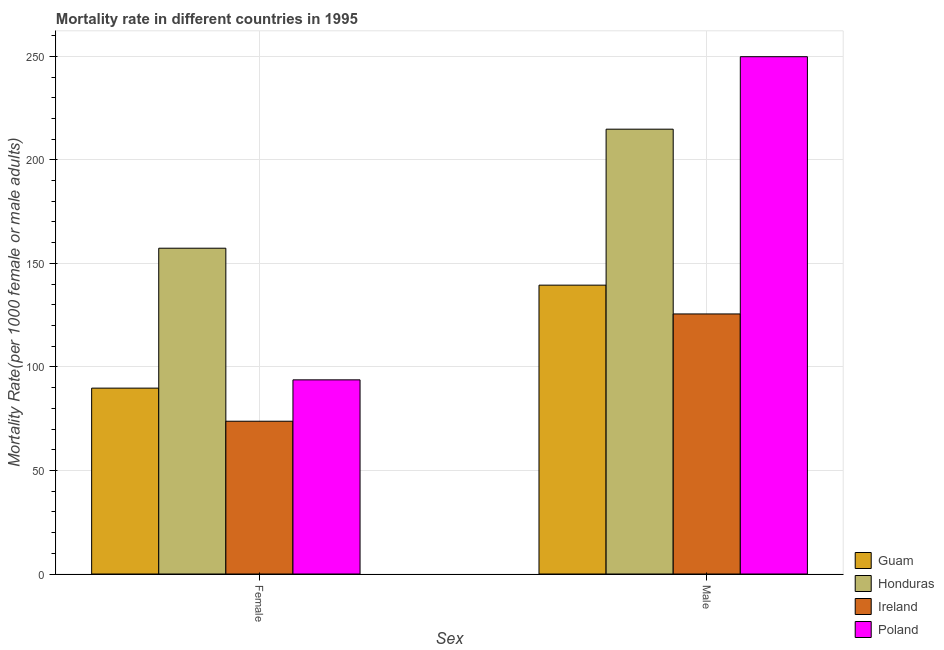How many groups of bars are there?
Provide a succinct answer. 2. Are the number of bars on each tick of the X-axis equal?
Make the answer very short. Yes. How many bars are there on the 2nd tick from the left?
Provide a succinct answer. 4. How many bars are there on the 2nd tick from the right?
Your response must be concise. 4. What is the male mortality rate in Ireland?
Offer a very short reply. 125.59. Across all countries, what is the maximum female mortality rate?
Give a very brief answer. 157.34. Across all countries, what is the minimum male mortality rate?
Your answer should be very brief. 125.59. In which country was the female mortality rate maximum?
Ensure brevity in your answer.  Honduras. In which country was the female mortality rate minimum?
Provide a succinct answer. Ireland. What is the total female mortality rate in the graph?
Offer a very short reply. 414.65. What is the difference between the female mortality rate in Guam and that in Poland?
Give a very brief answer. -4. What is the difference between the male mortality rate in Honduras and the female mortality rate in Ireland?
Provide a succinct answer. 141.05. What is the average male mortality rate per country?
Provide a short and direct response. 182.44. What is the difference between the female mortality rate and male mortality rate in Poland?
Provide a succinct answer. -156.07. What is the ratio of the female mortality rate in Honduras to that in Ireland?
Make the answer very short. 2.13. Is the female mortality rate in Ireland less than that in Poland?
Provide a short and direct response. Yes. What does the 3rd bar from the left in Male represents?
Your response must be concise. Ireland. What does the 4th bar from the right in Male represents?
Your answer should be compact. Guam. How many bars are there?
Offer a very short reply. 8. Are all the bars in the graph horizontal?
Keep it short and to the point. No. Are the values on the major ticks of Y-axis written in scientific E-notation?
Keep it short and to the point. No. How many legend labels are there?
Ensure brevity in your answer.  4. How are the legend labels stacked?
Provide a short and direct response. Vertical. What is the title of the graph?
Your response must be concise. Mortality rate in different countries in 1995. What is the label or title of the X-axis?
Your answer should be compact. Sex. What is the label or title of the Y-axis?
Your response must be concise. Mortality Rate(per 1000 female or male adults). What is the Mortality Rate(per 1000 female or male adults) of Guam in Female?
Your answer should be compact. 89.77. What is the Mortality Rate(per 1000 female or male adults) in Honduras in Female?
Offer a terse response. 157.34. What is the Mortality Rate(per 1000 female or male adults) of Ireland in Female?
Make the answer very short. 73.78. What is the Mortality Rate(per 1000 female or male adults) in Poland in Female?
Provide a succinct answer. 93.76. What is the Mortality Rate(per 1000 female or male adults) of Guam in Male?
Provide a succinct answer. 139.5. What is the Mortality Rate(per 1000 female or male adults) of Honduras in Male?
Keep it short and to the point. 214.83. What is the Mortality Rate(per 1000 female or male adults) in Ireland in Male?
Provide a short and direct response. 125.59. What is the Mortality Rate(per 1000 female or male adults) of Poland in Male?
Your response must be concise. 249.83. Across all Sex, what is the maximum Mortality Rate(per 1000 female or male adults) in Guam?
Make the answer very short. 139.5. Across all Sex, what is the maximum Mortality Rate(per 1000 female or male adults) in Honduras?
Give a very brief answer. 214.83. Across all Sex, what is the maximum Mortality Rate(per 1000 female or male adults) in Ireland?
Your answer should be compact. 125.59. Across all Sex, what is the maximum Mortality Rate(per 1000 female or male adults) of Poland?
Your answer should be very brief. 249.83. Across all Sex, what is the minimum Mortality Rate(per 1000 female or male adults) in Guam?
Make the answer very short. 89.77. Across all Sex, what is the minimum Mortality Rate(per 1000 female or male adults) in Honduras?
Keep it short and to the point. 157.34. Across all Sex, what is the minimum Mortality Rate(per 1000 female or male adults) in Ireland?
Make the answer very short. 73.78. Across all Sex, what is the minimum Mortality Rate(per 1000 female or male adults) in Poland?
Ensure brevity in your answer.  93.76. What is the total Mortality Rate(per 1000 female or male adults) of Guam in the graph?
Offer a terse response. 229.26. What is the total Mortality Rate(per 1000 female or male adults) in Honduras in the graph?
Offer a terse response. 372.17. What is the total Mortality Rate(per 1000 female or male adults) in Ireland in the graph?
Your answer should be very brief. 199.37. What is the total Mortality Rate(per 1000 female or male adults) of Poland in the graph?
Offer a terse response. 343.59. What is the difference between the Mortality Rate(per 1000 female or male adults) in Guam in Female and that in Male?
Give a very brief answer. -49.73. What is the difference between the Mortality Rate(per 1000 female or male adults) in Honduras in Female and that in Male?
Your answer should be very brief. -57.49. What is the difference between the Mortality Rate(per 1000 female or male adults) of Ireland in Female and that in Male?
Your answer should be very brief. -51.81. What is the difference between the Mortality Rate(per 1000 female or male adults) in Poland in Female and that in Male?
Your response must be concise. -156.07. What is the difference between the Mortality Rate(per 1000 female or male adults) in Guam in Female and the Mortality Rate(per 1000 female or male adults) in Honduras in Male?
Your response must be concise. -125.06. What is the difference between the Mortality Rate(per 1000 female or male adults) in Guam in Female and the Mortality Rate(per 1000 female or male adults) in Ireland in Male?
Provide a short and direct response. -35.83. What is the difference between the Mortality Rate(per 1000 female or male adults) in Guam in Female and the Mortality Rate(per 1000 female or male adults) in Poland in Male?
Your answer should be compact. -160.07. What is the difference between the Mortality Rate(per 1000 female or male adults) in Honduras in Female and the Mortality Rate(per 1000 female or male adults) in Ireland in Male?
Your answer should be compact. 31.75. What is the difference between the Mortality Rate(per 1000 female or male adults) of Honduras in Female and the Mortality Rate(per 1000 female or male adults) of Poland in Male?
Make the answer very short. -92.49. What is the difference between the Mortality Rate(per 1000 female or male adults) of Ireland in Female and the Mortality Rate(per 1000 female or male adults) of Poland in Male?
Ensure brevity in your answer.  -176.05. What is the average Mortality Rate(per 1000 female or male adults) in Guam per Sex?
Make the answer very short. 114.63. What is the average Mortality Rate(per 1000 female or male adults) in Honduras per Sex?
Provide a short and direct response. 186.08. What is the average Mortality Rate(per 1000 female or male adults) in Ireland per Sex?
Ensure brevity in your answer.  99.69. What is the average Mortality Rate(per 1000 female or male adults) in Poland per Sex?
Offer a very short reply. 171.8. What is the difference between the Mortality Rate(per 1000 female or male adults) of Guam and Mortality Rate(per 1000 female or male adults) of Honduras in Female?
Provide a succinct answer. -67.57. What is the difference between the Mortality Rate(per 1000 female or male adults) in Guam and Mortality Rate(per 1000 female or male adults) in Ireland in Female?
Your answer should be compact. 15.98. What is the difference between the Mortality Rate(per 1000 female or male adults) in Guam and Mortality Rate(per 1000 female or male adults) in Poland in Female?
Make the answer very short. -4. What is the difference between the Mortality Rate(per 1000 female or male adults) in Honduras and Mortality Rate(per 1000 female or male adults) in Ireland in Female?
Your response must be concise. 83.56. What is the difference between the Mortality Rate(per 1000 female or male adults) of Honduras and Mortality Rate(per 1000 female or male adults) of Poland in Female?
Your answer should be very brief. 63.58. What is the difference between the Mortality Rate(per 1000 female or male adults) of Ireland and Mortality Rate(per 1000 female or male adults) of Poland in Female?
Offer a very short reply. -19.98. What is the difference between the Mortality Rate(per 1000 female or male adults) in Guam and Mortality Rate(per 1000 female or male adults) in Honduras in Male?
Offer a very short reply. -75.33. What is the difference between the Mortality Rate(per 1000 female or male adults) of Guam and Mortality Rate(per 1000 female or male adults) of Ireland in Male?
Offer a very short reply. 13.91. What is the difference between the Mortality Rate(per 1000 female or male adults) of Guam and Mortality Rate(per 1000 female or male adults) of Poland in Male?
Your answer should be compact. -110.33. What is the difference between the Mortality Rate(per 1000 female or male adults) in Honduras and Mortality Rate(per 1000 female or male adults) in Ireland in Male?
Your answer should be very brief. 89.24. What is the difference between the Mortality Rate(per 1000 female or male adults) in Honduras and Mortality Rate(per 1000 female or male adults) in Poland in Male?
Offer a very short reply. -35.01. What is the difference between the Mortality Rate(per 1000 female or male adults) of Ireland and Mortality Rate(per 1000 female or male adults) of Poland in Male?
Offer a terse response. -124.24. What is the ratio of the Mortality Rate(per 1000 female or male adults) in Guam in Female to that in Male?
Your answer should be compact. 0.64. What is the ratio of the Mortality Rate(per 1000 female or male adults) in Honduras in Female to that in Male?
Give a very brief answer. 0.73. What is the ratio of the Mortality Rate(per 1000 female or male adults) of Ireland in Female to that in Male?
Provide a short and direct response. 0.59. What is the ratio of the Mortality Rate(per 1000 female or male adults) of Poland in Female to that in Male?
Offer a very short reply. 0.38. What is the difference between the highest and the second highest Mortality Rate(per 1000 female or male adults) of Guam?
Make the answer very short. 49.73. What is the difference between the highest and the second highest Mortality Rate(per 1000 female or male adults) in Honduras?
Your answer should be compact. 57.49. What is the difference between the highest and the second highest Mortality Rate(per 1000 female or male adults) of Ireland?
Make the answer very short. 51.81. What is the difference between the highest and the second highest Mortality Rate(per 1000 female or male adults) of Poland?
Provide a succinct answer. 156.07. What is the difference between the highest and the lowest Mortality Rate(per 1000 female or male adults) of Guam?
Offer a very short reply. 49.73. What is the difference between the highest and the lowest Mortality Rate(per 1000 female or male adults) in Honduras?
Provide a succinct answer. 57.49. What is the difference between the highest and the lowest Mortality Rate(per 1000 female or male adults) of Ireland?
Your response must be concise. 51.81. What is the difference between the highest and the lowest Mortality Rate(per 1000 female or male adults) of Poland?
Offer a terse response. 156.07. 